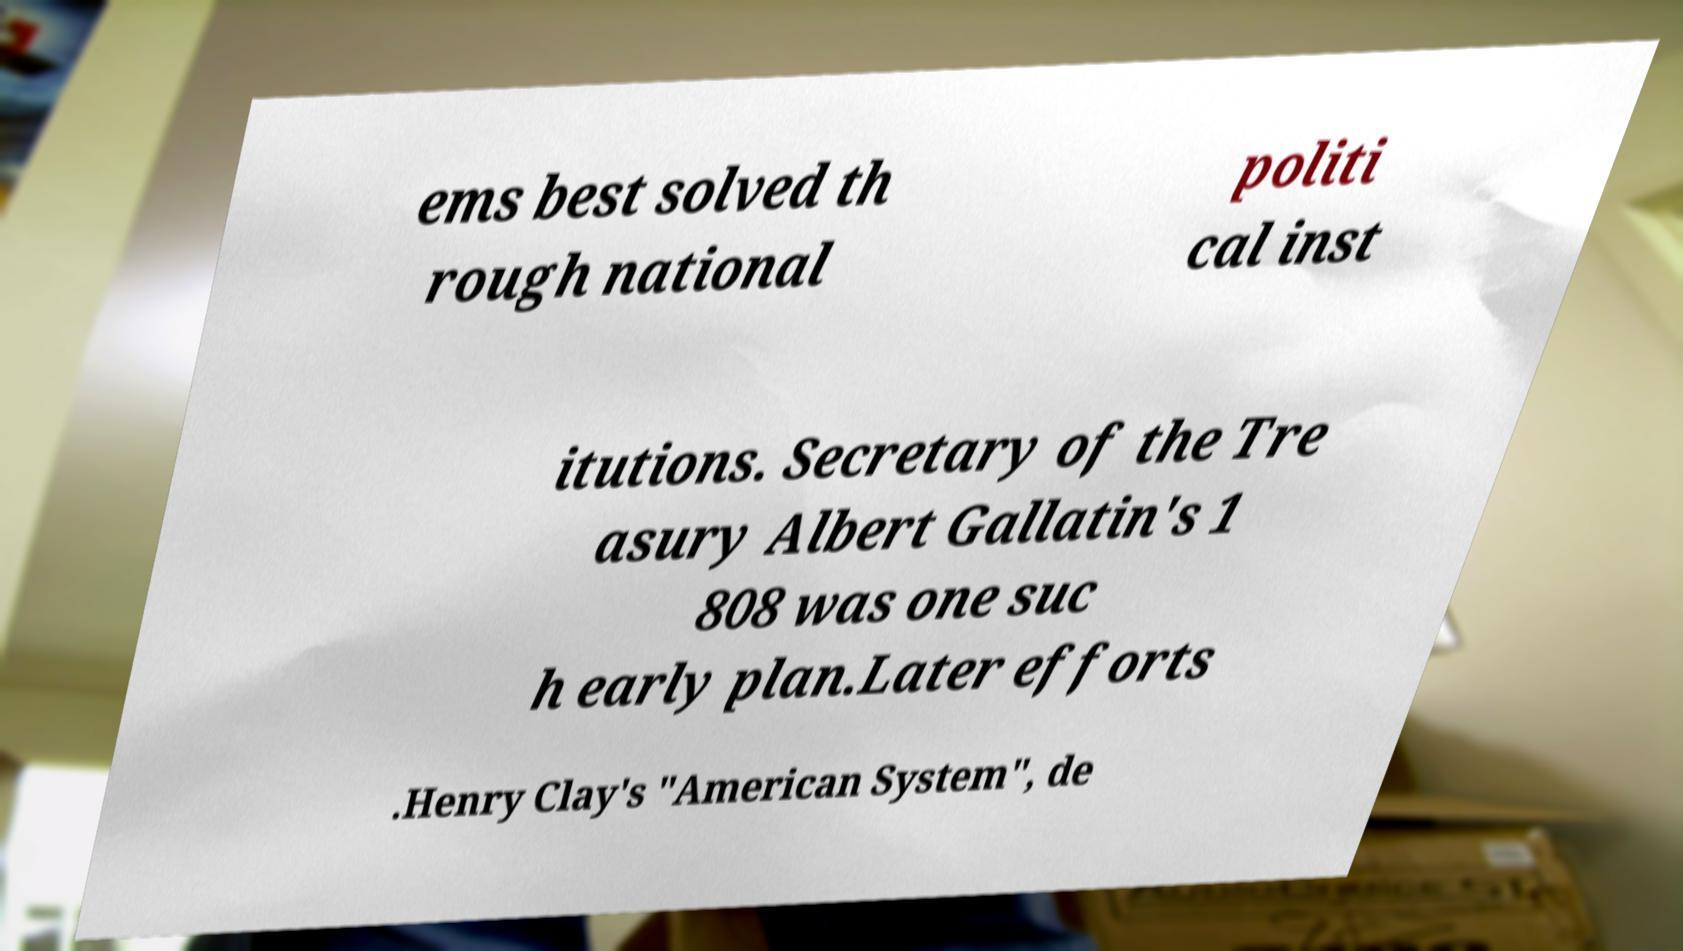Please identify and transcribe the text found in this image. ems best solved th rough national politi cal inst itutions. Secretary of the Tre asury Albert Gallatin's 1 808 was one suc h early plan.Later efforts .Henry Clay's "American System", de 